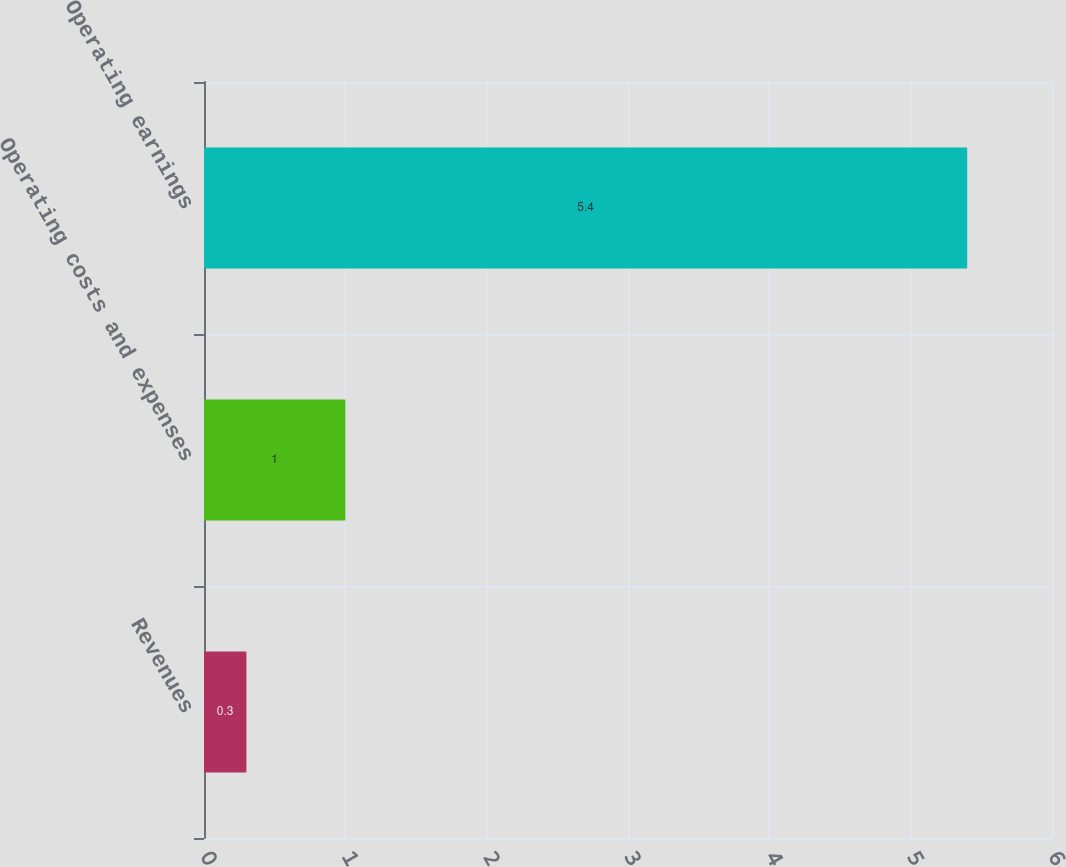Convert chart. <chart><loc_0><loc_0><loc_500><loc_500><bar_chart><fcel>Revenues<fcel>Operating costs and expenses<fcel>Operating earnings<nl><fcel>0.3<fcel>1<fcel>5.4<nl></chart> 